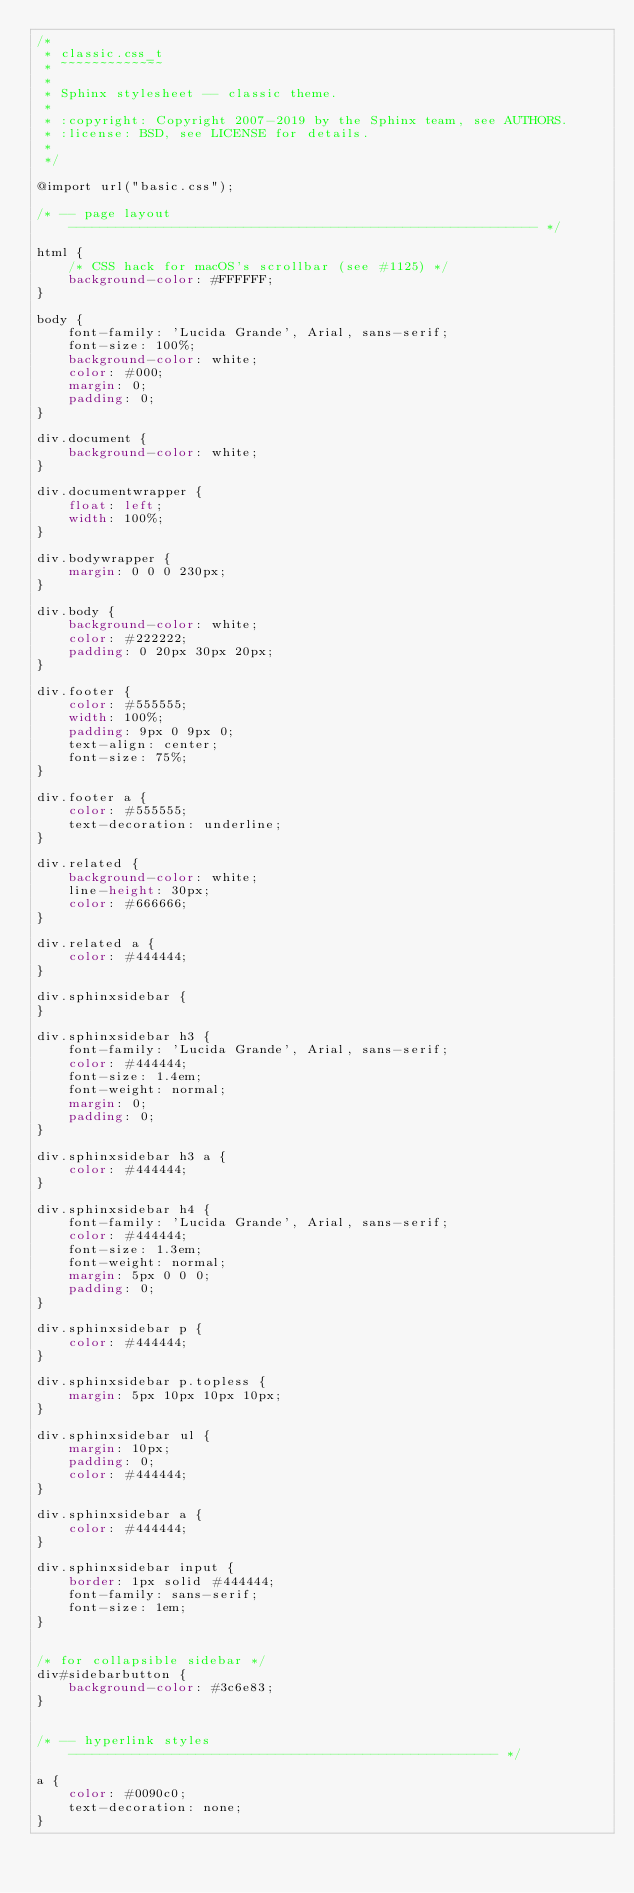Convert code to text. <code><loc_0><loc_0><loc_500><loc_500><_CSS_>/*
 * classic.css_t
 * ~~~~~~~~~~~~~
 *
 * Sphinx stylesheet -- classic theme.
 *
 * :copyright: Copyright 2007-2019 by the Sphinx team, see AUTHORS.
 * :license: BSD, see LICENSE for details.
 *
 */

@import url("basic.css");

/* -- page layout ----------------------------------------------------------- */

html {
    /* CSS hack for macOS's scrollbar (see #1125) */
    background-color: #FFFFFF;
}

body {
    font-family: 'Lucida Grande', Arial, sans-serif;
    font-size: 100%;
    background-color: white;
    color: #000;
    margin: 0;
    padding: 0;
}

div.document {
    background-color: white;
}

div.documentwrapper {
    float: left;
    width: 100%;
}

div.bodywrapper {
    margin: 0 0 0 230px;
}

div.body {
    background-color: white;
    color: #222222;
    padding: 0 20px 30px 20px;
}

div.footer {
    color: #555555;
    width: 100%;
    padding: 9px 0 9px 0;
    text-align: center;
    font-size: 75%;
}

div.footer a {
    color: #555555;
    text-decoration: underline;
}

div.related {
    background-color: white;
    line-height: 30px;
    color: #666666;
}

div.related a {
    color: #444444;
}

div.sphinxsidebar {
}

div.sphinxsidebar h3 {
    font-family: 'Lucida Grande', Arial, sans-serif;
    color: #444444;
    font-size: 1.4em;
    font-weight: normal;
    margin: 0;
    padding: 0;
}

div.sphinxsidebar h3 a {
    color: #444444;
}

div.sphinxsidebar h4 {
    font-family: 'Lucida Grande', Arial, sans-serif;
    color: #444444;
    font-size: 1.3em;
    font-weight: normal;
    margin: 5px 0 0 0;
    padding: 0;
}

div.sphinxsidebar p {
    color: #444444;
}

div.sphinxsidebar p.topless {
    margin: 5px 10px 10px 10px;
}

div.sphinxsidebar ul {
    margin: 10px;
    padding: 0;
    color: #444444;
}

div.sphinxsidebar a {
    color: #444444;
}

div.sphinxsidebar input {
    border: 1px solid #444444;
    font-family: sans-serif;
    font-size: 1em;
}


/* for collapsible sidebar */
div#sidebarbutton {
    background-color: #3c6e83;
}


/* -- hyperlink styles ------------------------------------------------------ */

a {
    color: #0090c0;
    text-decoration: none;
}
</code> 